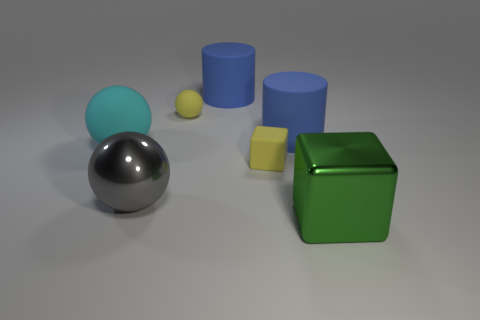Subtract all big gray spheres. How many spheres are left? 2 Subtract all cyan balls. How many balls are left? 2 Subtract 1 spheres. How many spheres are left? 2 Add 1 blue matte objects. How many objects exist? 8 Subtract all balls. How many objects are left? 4 Subtract all yellow metallic objects. Subtract all cyan things. How many objects are left? 6 Add 1 large blue matte objects. How many large blue matte objects are left? 3 Add 7 small brown metallic spheres. How many small brown metallic spheres exist? 7 Subtract 0 cyan cylinders. How many objects are left? 7 Subtract all red spheres. Subtract all green cylinders. How many spheres are left? 3 